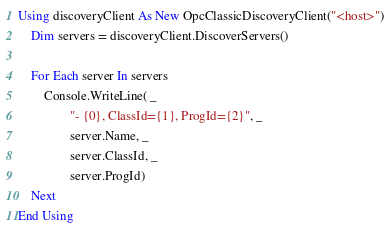Convert code to text. <code><loc_0><loc_0><loc_500><loc_500><_VisualBasic_>Using discoveryClient As New OpcClassicDiscoveryClient("<host>")
    Dim servers = discoveryClient.DiscoverServers()

    For Each server In servers
        Console.WriteLine( _
                "- {0}, ClassId={1}, ProgId={2}", _
                server.Name, _
                server.ClassId, _
                server.ProgId)
    Next
End Using</code> 